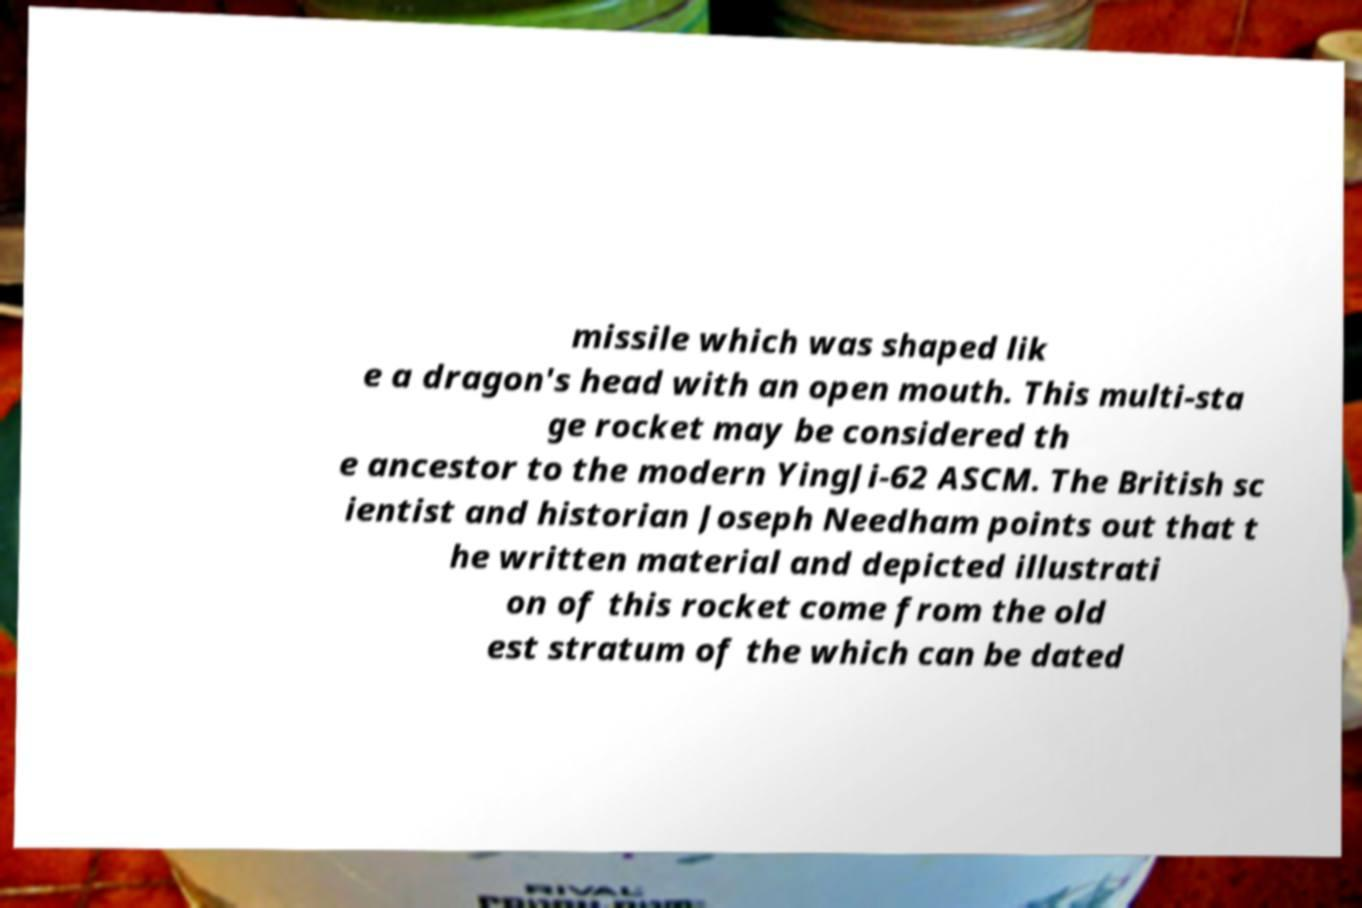Please read and relay the text visible in this image. What does it say? missile which was shaped lik e a dragon's head with an open mouth. This multi-sta ge rocket may be considered th e ancestor to the modern YingJi-62 ASCM. The British sc ientist and historian Joseph Needham points out that t he written material and depicted illustrati on of this rocket come from the old est stratum of the which can be dated 